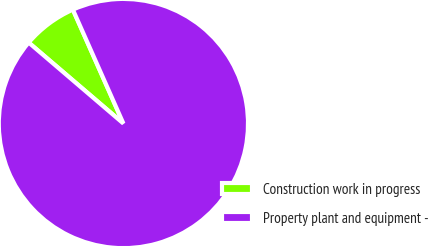Convert chart to OTSL. <chart><loc_0><loc_0><loc_500><loc_500><pie_chart><fcel>Construction work in progress<fcel>Property plant and equipment -<nl><fcel>7.1%<fcel>92.9%<nl></chart> 